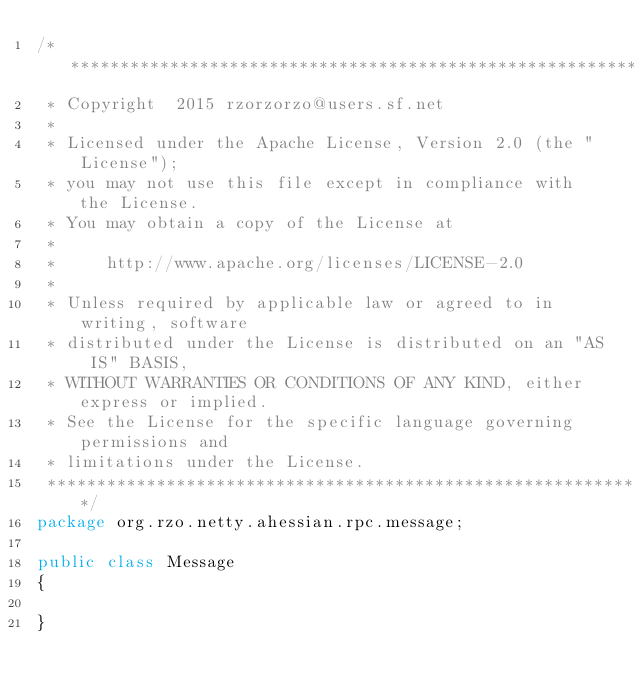Convert code to text. <code><loc_0><loc_0><loc_500><loc_500><_Java_>/*******************************************************************************
 * Copyright  2015 rzorzorzo@users.sf.net
 *
 * Licensed under the Apache License, Version 2.0 (the "License");
 * you may not use this file except in compliance with the License.
 * You may obtain a copy of the License at
 *
 *     http://www.apache.org/licenses/LICENSE-2.0
 *
 * Unless required by applicable law or agreed to in writing, software
 * distributed under the License is distributed on an "AS IS" BASIS,
 * WITHOUT WARRANTIES OR CONDITIONS OF ANY KIND, either express or implied.
 * See the License for the specific language governing permissions and
 * limitations under the License.
 *******************************************************************************/
package org.rzo.netty.ahessian.rpc.message;

public class Message
{

}
</code> 